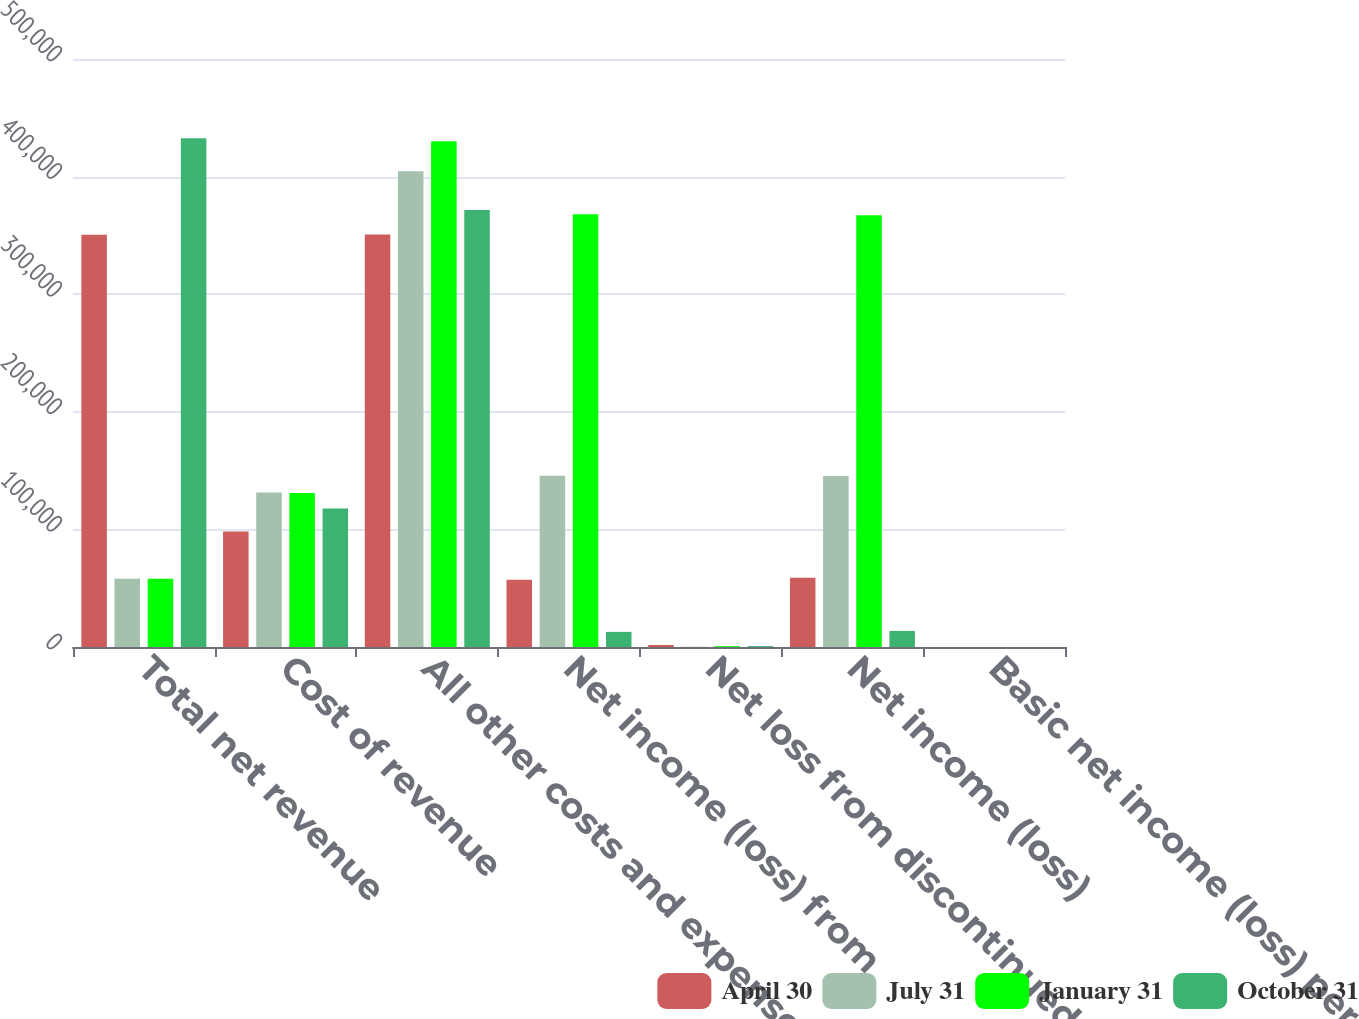Convert chart. <chart><loc_0><loc_0><loc_500><loc_500><stacked_bar_chart><ecel><fcel>Total net revenue<fcel>Cost of revenue<fcel>All other costs and expenses<fcel>Net income (loss) from<fcel>Net loss from discontinued<fcel>Net income (loss)<fcel>Basic net income (loss) per<nl><fcel>April 30<fcel>350493<fcel>98207<fcel>350805<fcel>57200<fcel>1730<fcel>58930<fcel>0.17<nl><fcel>July 31<fcel>58065<fcel>131454<fcel>404466<fcel>145580<fcel>218<fcel>145362<fcel>0.42<nl><fcel>January 31<fcel>58065<fcel>130982<fcel>430083<fcel>367947<fcel>736<fcel>367211<fcel>1.08<nl><fcel>October 31<fcel>432672<fcel>117877<fcel>371503<fcel>12859<fcel>781<fcel>13640<fcel>0.04<nl></chart> 